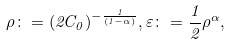Convert formula to latex. <formula><loc_0><loc_0><loc_500><loc_500>\rho \colon = ( 2 C _ { 0 } ) ^ { - \frac { 1 } { ( 1 - \alpha ) } } , \varepsilon \colon = \frac { 1 } { 2 } \rho ^ { \alpha } ,</formula> 